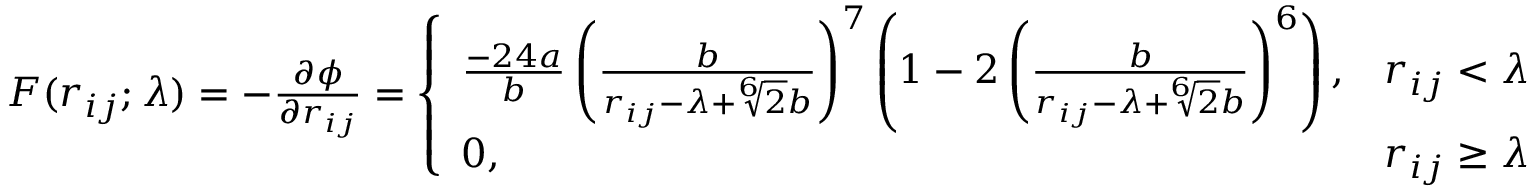Convert formula to latex. <formula><loc_0><loc_0><loc_500><loc_500>\begin{array} { r } { F ( r _ { i j } ; \lambda ) = - \frac { \partial \phi } { \partial r _ { i j } } = \left \{ \begin{array} { l l } { \frac { - 2 4 a } { b } \left ( \frac { b } { r _ { i j } - \lambda + \sqrt { [ } 6 ] { 2 } b } \right ) ^ { 7 } \left ( 1 - 2 \left ( \frac { b } { r _ { i j } - \lambda + \sqrt { [ } 6 ] { 2 } b } \right ) ^ { 6 } \right ) , } & { r _ { i j } < \lambda } \\ { 0 , } & { r _ { i j } \geq \lambda } \end{array} } \end{array}</formula> 